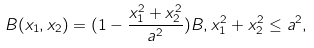<formula> <loc_0><loc_0><loc_500><loc_500>B ( x _ { 1 } , x _ { 2 } ) = ( 1 - \frac { x _ { 1 } ^ { 2 } + x _ { 2 } ^ { 2 } } { a ^ { 2 } } ) B , x _ { 1 } ^ { 2 } + x _ { 2 } ^ { 2 } \leq a ^ { 2 } ,</formula> 